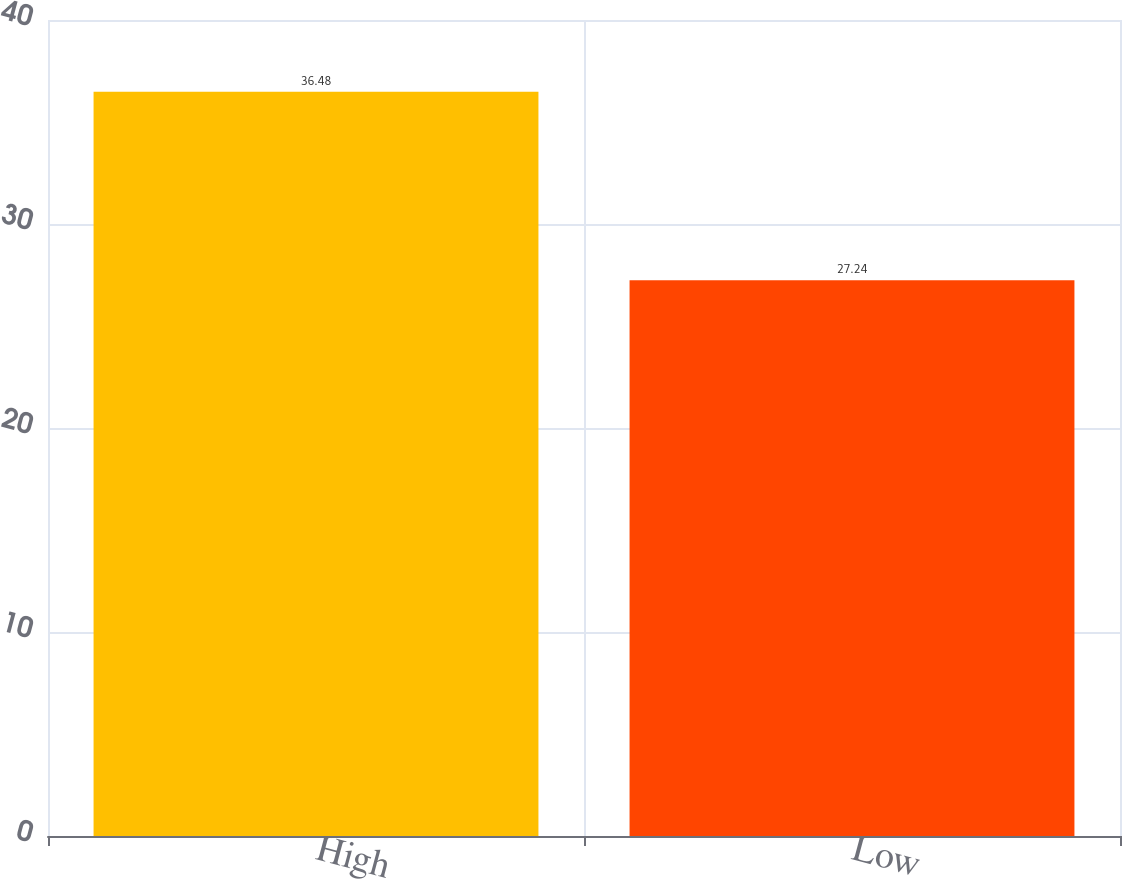<chart> <loc_0><loc_0><loc_500><loc_500><bar_chart><fcel>High<fcel>Low<nl><fcel>36.48<fcel>27.24<nl></chart> 